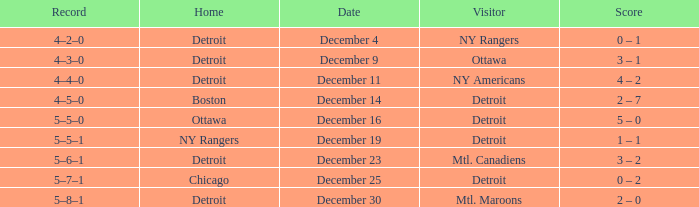What visitor has December 14 as the date? Detroit. Could you parse the entire table? {'header': ['Record', 'Home', 'Date', 'Visitor', 'Score'], 'rows': [['4–2–0', 'Detroit', 'December 4', 'NY Rangers', '0 – 1'], ['4–3–0', 'Detroit', 'December 9', 'Ottawa', '3 – 1'], ['4–4–0', 'Detroit', 'December 11', 'NY Americans', '4 – 2'], ['4–5–0', 'Boston', 'December 14', 'Detroit', '2 – 7'], ['5–5–0', 'Ottawa', 'December 16', 'Detroit', '5 – 0'], ['5–5–1', 'NY Rangers', 'December 19', 'Detroit', '1 – 1'], ['5–6–1', 'Detroit', 'December 23', 'Mtl. Canadiens', '3 – 2'], ['5–7–1', 'Chicago', 'December 25', 'Detroit', '0 – 2'], ['5–8–1', 'Detroit', 'December 30', 'Mtl. Maroons', '2 – 0']]} 